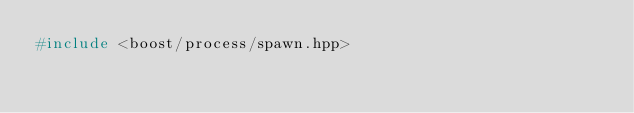Convert code to text. <code><loc_0><loc_0><loc_500><loc_500><_C++_>#include <boost/process/spawn.hpp>
</code> 